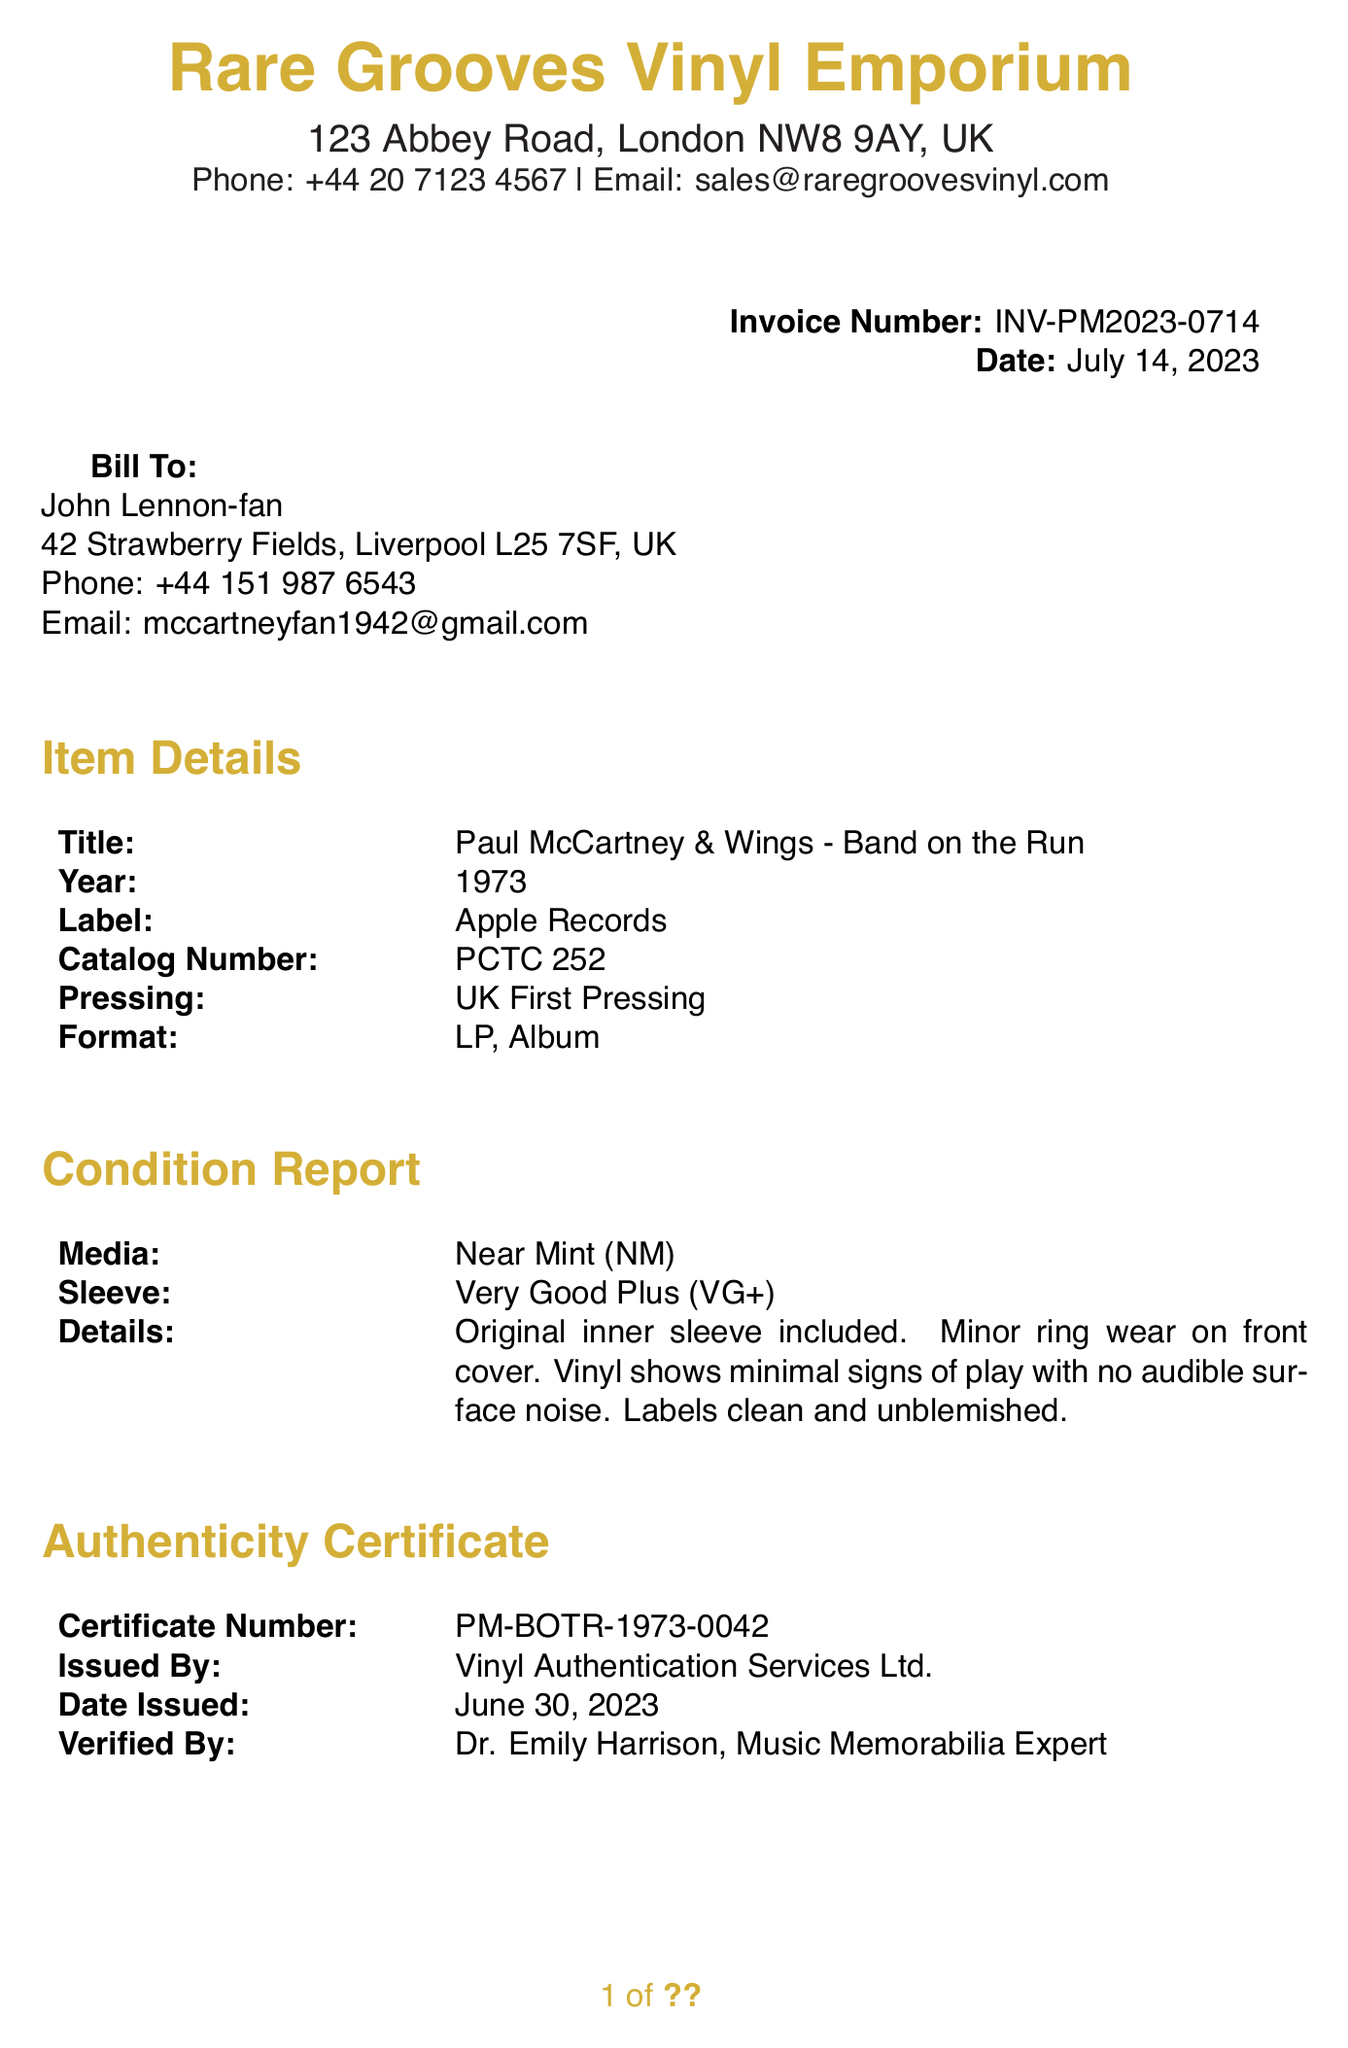What is the invoice number? The invoice number is a unique identifier for the document, provided at the top right corner.
Answer: INV-PM2023-0714 Who is the buyer? The buyer's name is listed in the "Bill To" section.
Answer: John Lennon-fan What is the total price? The total price is calculated from the base price and shipping insurance.
Answer: £1,250.00 What is the media condition of the vinyl? The media condition is described in the "Condition Report" section.
Answer: Near Mint (NM) When was the authenticity certificate issued? The issue date of the authenticity certificate is located in the "Authenticity Certificate" section.
Answer: June 30, 2023 What is the shipping method? The shipping method is specified in the shipping section of the document.
Answer: FedEx International Priority, fully insured Who verified the authenticity? The person who verified the authenticity is mentioned in the "Authenticity Certificate" section.
Answer: Dr. Emily Harrison, Music Memorabilia Expert What is the pressing type of the album? The type of pressing is indicated in the "Item Details" section of the invoice.
Answer: UK First Pressing What is the seller's email address? The seller's email address is provided in the contact information at the top of the document.
Answer: sales@raregroovesvinyl.com 